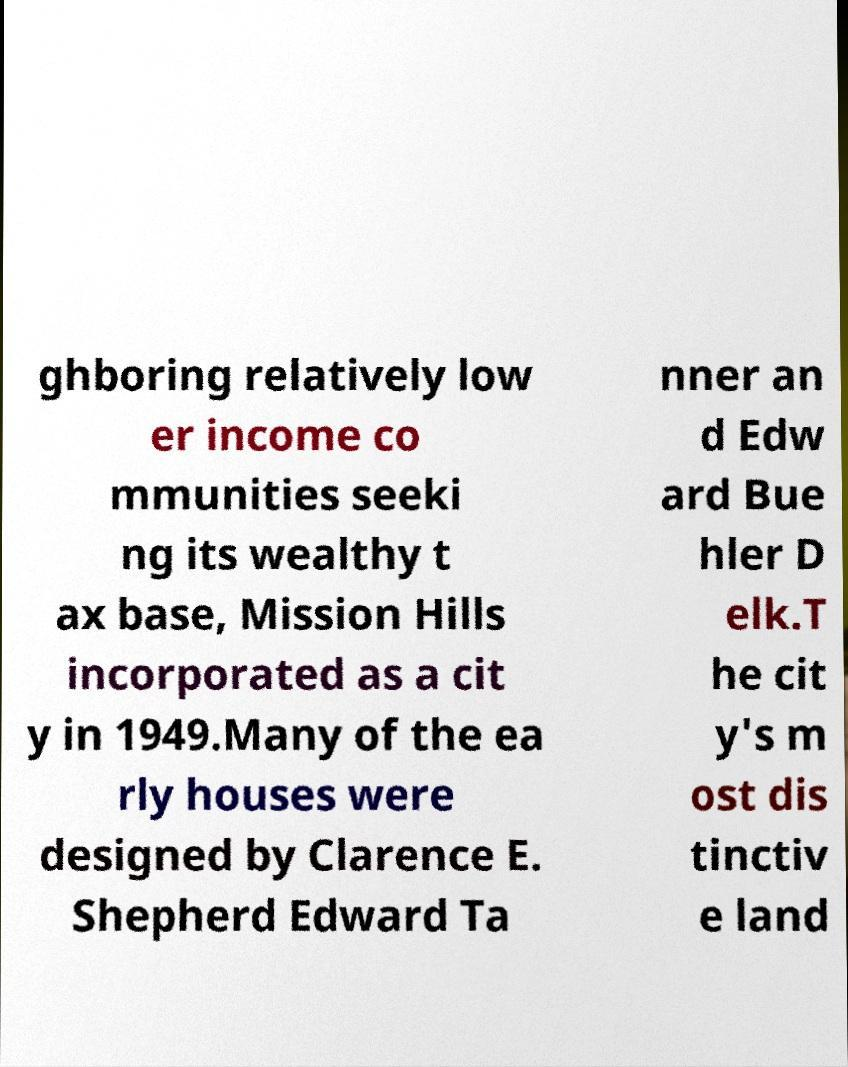Could you extract and type out the text from this image? ghboring relatively low er income co mmunities seeki ng its wealthy t ax base, Mission Hills incorporated as a cit y in 1949.Many of the ea rly houses were designed by Clarence E. Shepherd Edward Ta nner an d Edw ard Bue hler D elk.T he cit y's m ost dis tinctiv e land 